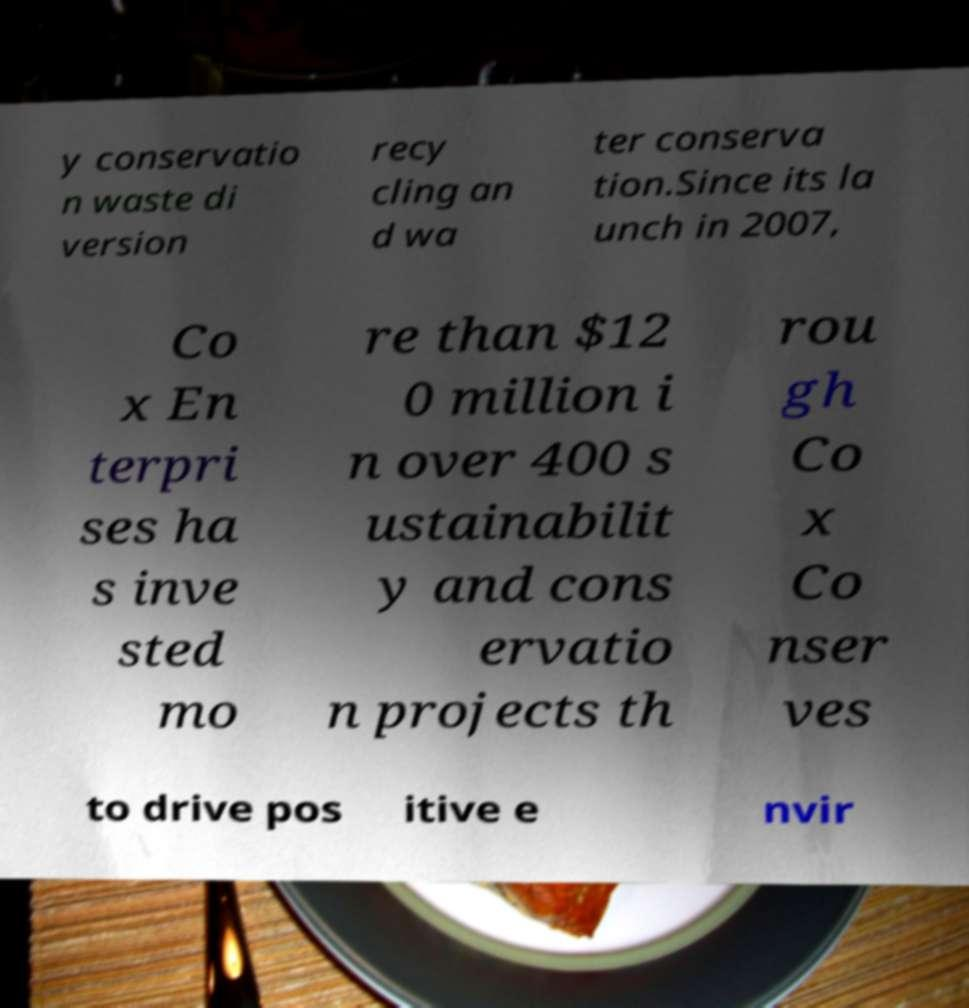Could you assist in decoding the text presented in this image and type it out clearly? y conservatio n waste di version recy cling an d wa ter conserva tion.Since its la unch in 2007, Co x En terpri ses ha s inve sted mo re than $12 0 million i n over 400 s ustainabilit y and cons ervatio n projects th rou gh Co x Co nser ves to drive pos itive e nvir 